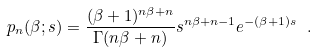Convert formula to latex. <formula><loc_0><loc_0><loc_500><loc_500>p _ { n } ( \beta ; s ) = \frac { ( \beta + 1 ) ^ { n \beta + n } } { \Gamma ( n \beta + n ) } s ^ { n \beta + n - 1 } e ^ { - ( \beta + 1 ) s } \ .</formula> 